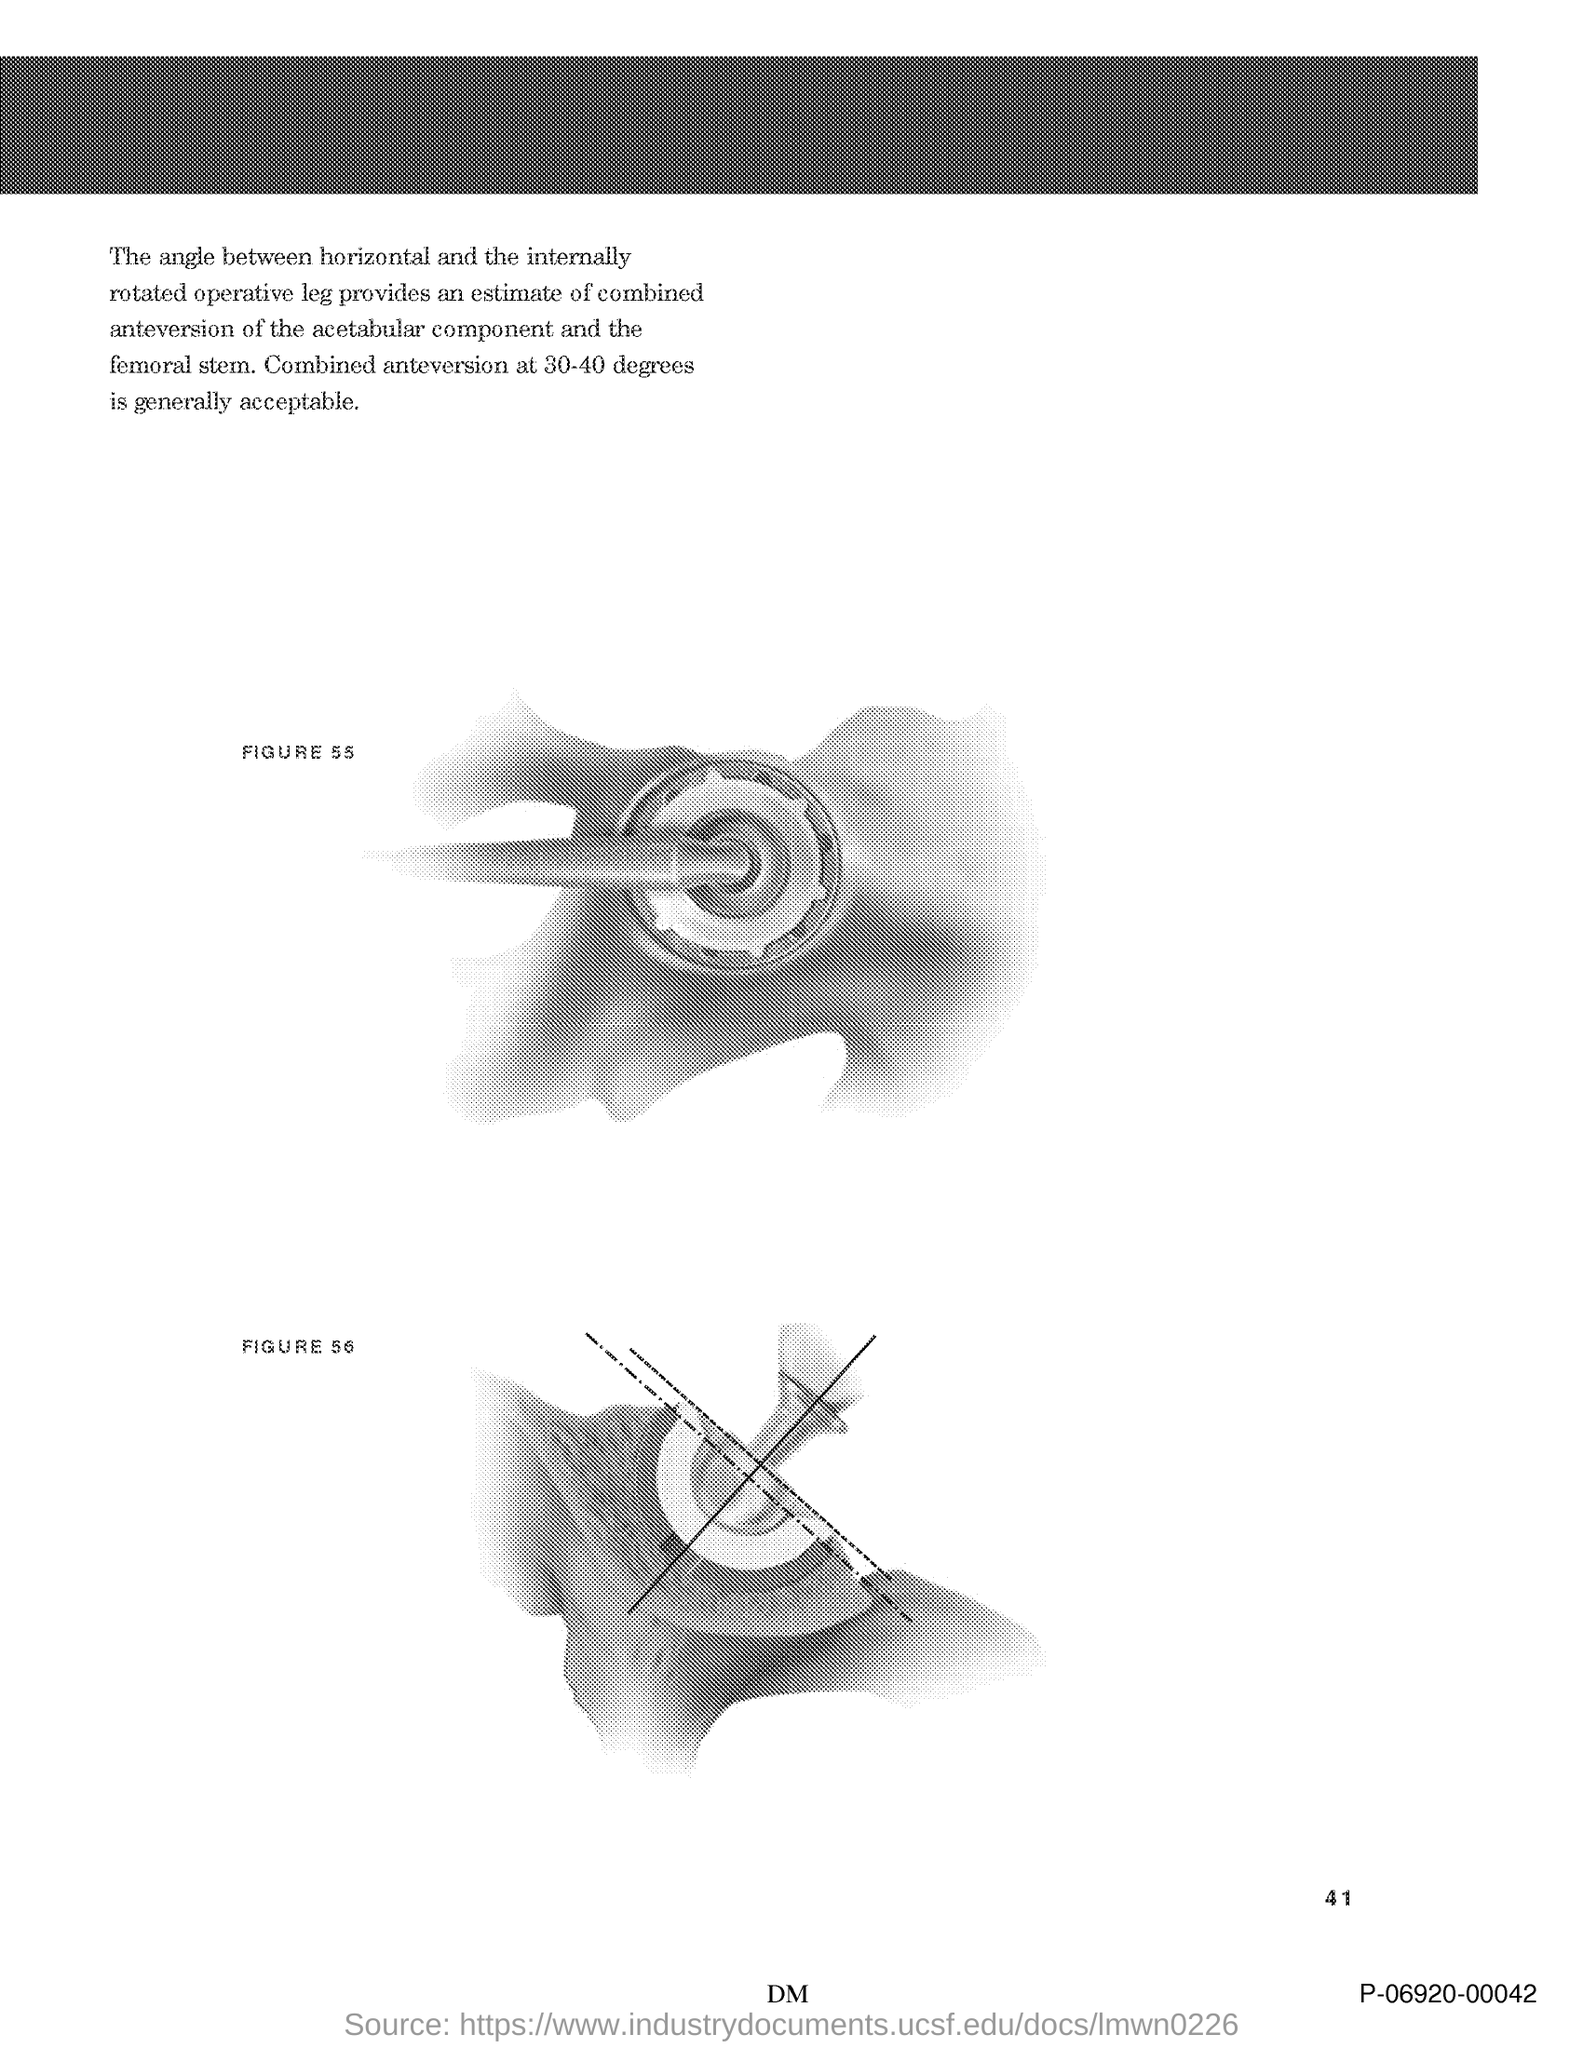Point out several critical features in this image. The page number is 41. 